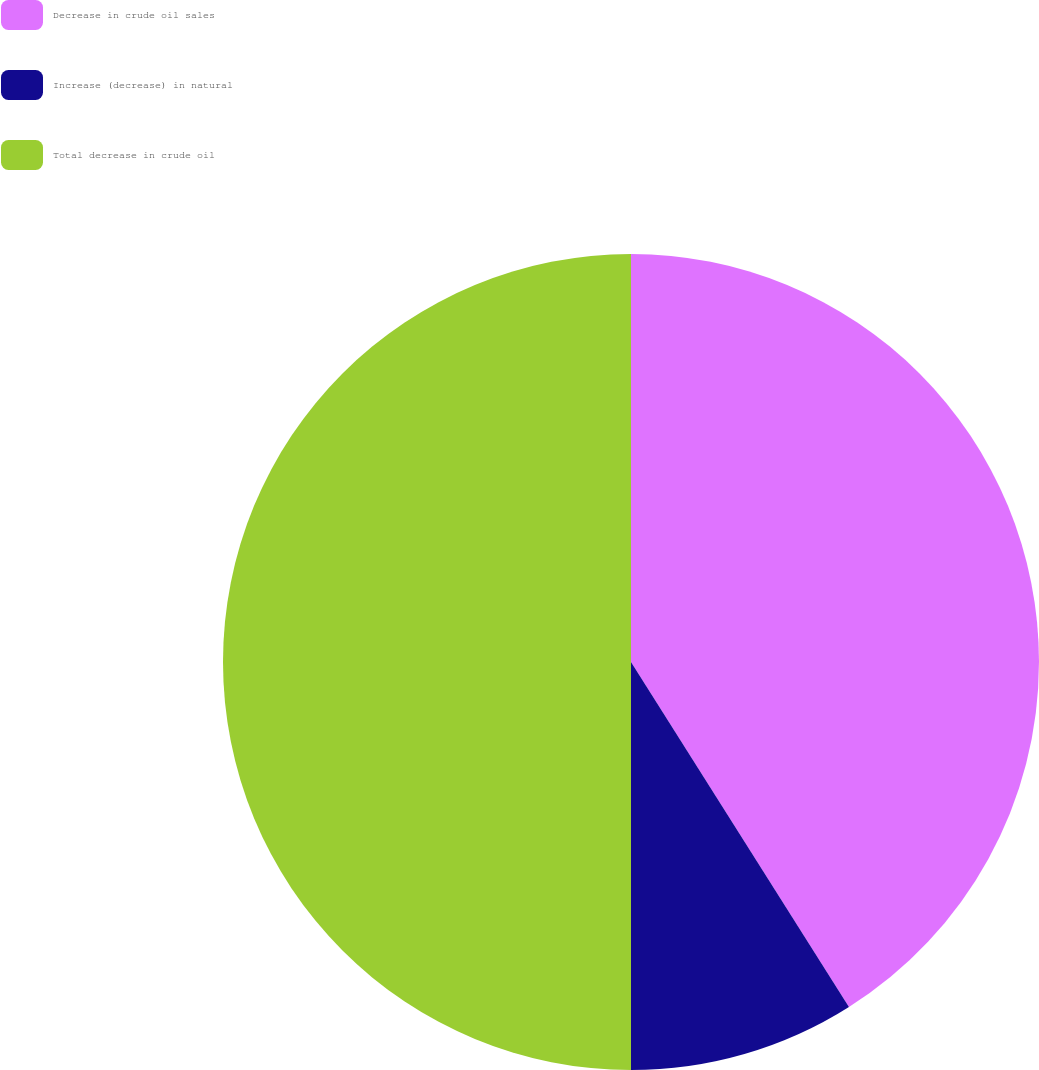<chart> <loc_0><loc_0><loc_500><loc_500><pie_chart><fcel>Decrease in crude oil sales<fcel>Increase (decrease) in natural<fcel>Total decrease in crude oil<nl><fcel>41.03%<fcel>8.97%<fcel>50.0%<nl></chart> 